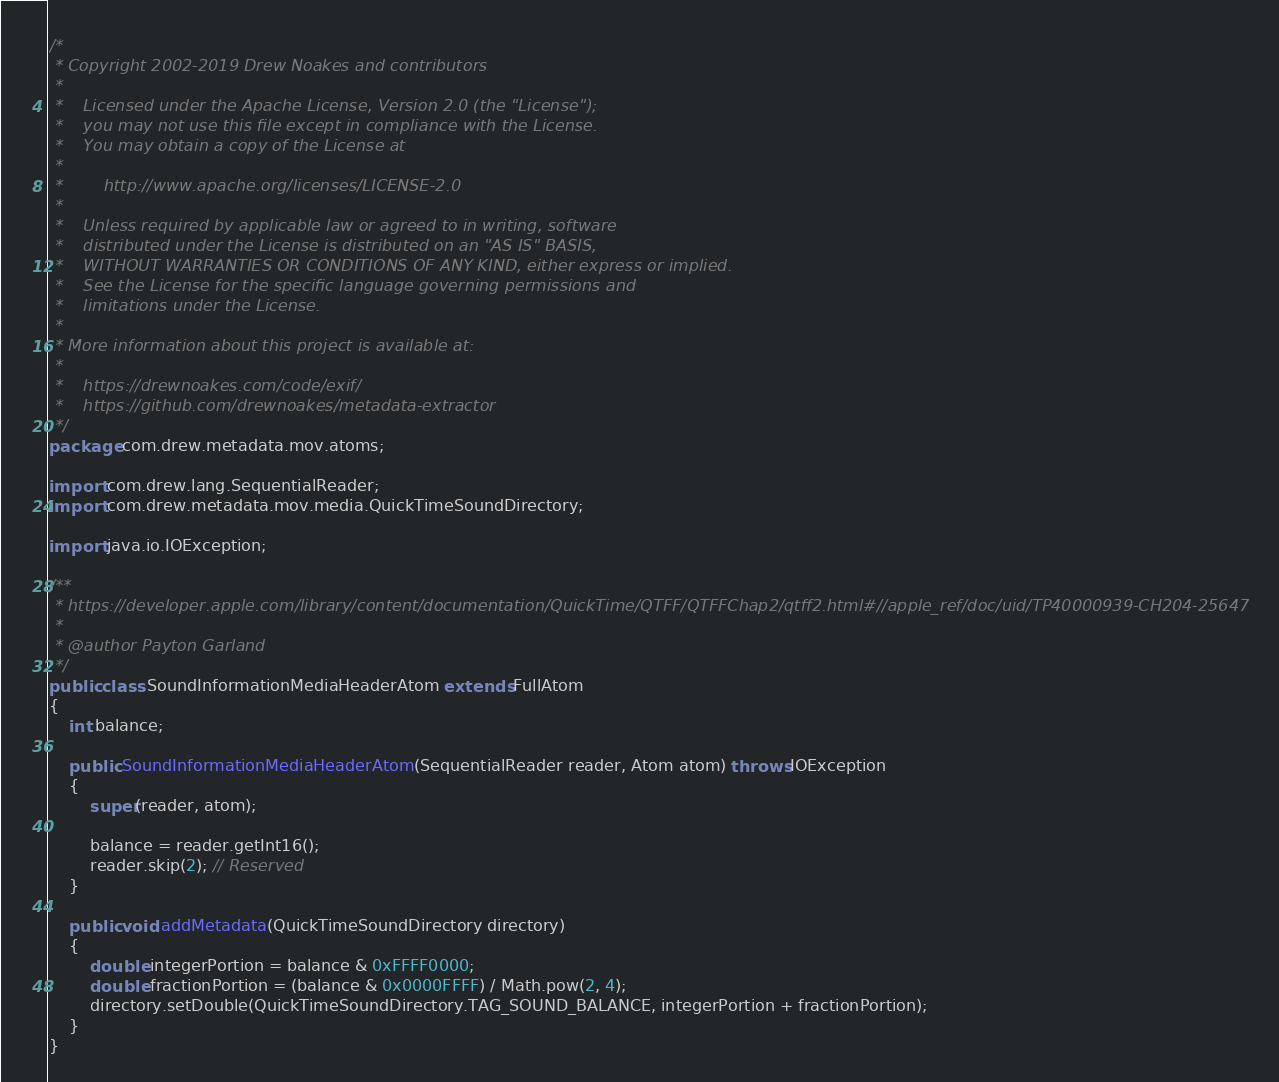Convert code to text. <code><loc_0><loc_0><loc_500><loc_500><_Java_>/*
 * Copyright 2002-2019 Drew Noakes and contributors
 *
 *    Licensed under the Apache License, Version 2.0 (the "License");
 *    you may not use this file except in compliance with the License.
 *    You may obtain a copy of the License at
 *
 *        http://www.apache.org/licenses/LICENSE-2.0
 *
 *    Unless required by applicable law or agreed to in writing, software
 *    distributed under the License is distributed on an "AS IS" BASIS,
 *    WITHOUT WARRANTIES OR CONDITIONS OF ANY KIND, either express or implied.
 *    See the License for the specific language governing permissions and
 *    limitations under the License.
 *
 * More information about this project is available at:
 *
 *    https://drewnoakes.com/code/exif/
 *    https://github.com/drewnoakes/metadata-extractor
 */
package com.drew.metadata.mov.atoms;

import com.drew.lang.SequentialReader;
import com.drew.metadata.mov.media.QuickTimeSoundDirectory;

import java.io.IOException;

/**
 * https://developer.apple.com/library/content/documentation/QuickTime/QTFF/QTFFChap2/qtff2.html#//apple_ref/doc/uid/TP40000939-CH204-25647
 *
 * @author Payton Garland
 */
public class SoundInformationMediaHeaderAtom extends FullAtom
{
    int balance;

    public SoundInformationMediaHeaderAtom(SequentialReader reader, Atom atom) throws IOException
    {
        super(reader, atom);

        balance = reader.getInt16();
        reader.skip(2); // Reserved
    }

    public void addMetadata(QuickTimeSoundDirectory directory)
    {
        double integerPortion = balance & 0xFFFF0000;
        double fractionPortion = (balance & 0x0000FFFF) / Math.pow(2, 4);
        directory.setDouble(QuickTimeSoundDirectory.TAG_SOUND_BALANCE, integerPortion + fractionPortion);
    }
}
</code> 